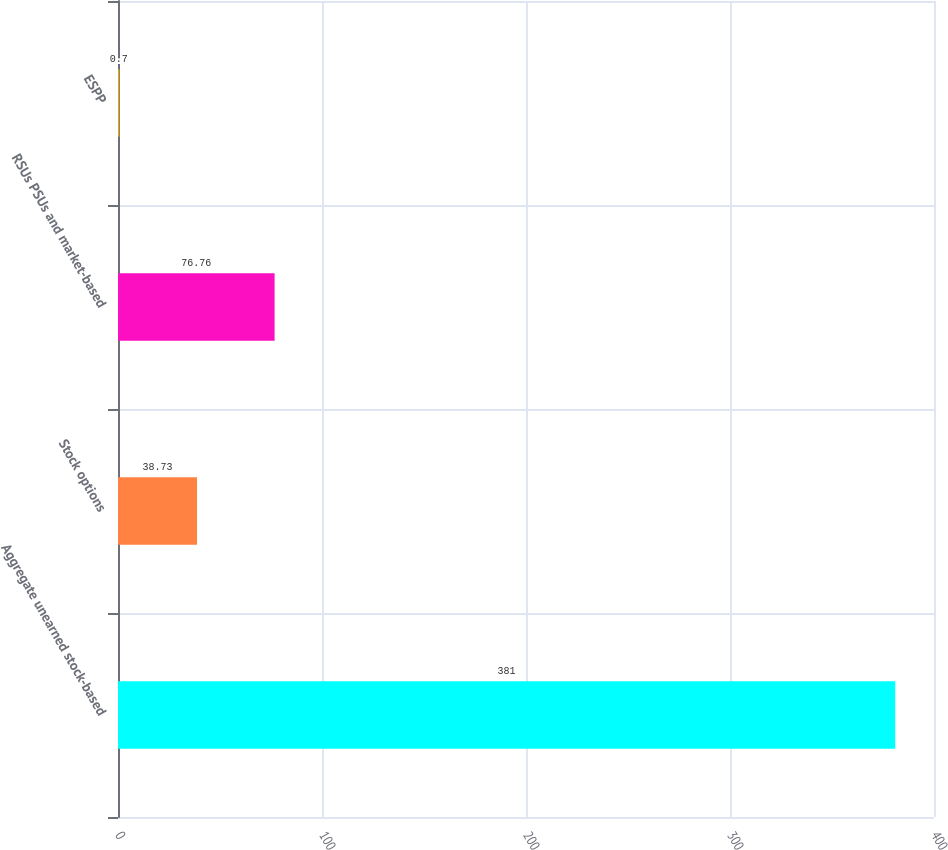Convert chart. <chart><loc_0><loc_0><loc_500><loc_500><bar_chart><fcel>Aggregate unearned stock-based<fcel>Stock options<fcel>RSUs PSUs and market-based<fcel>ESPP<nl><fcel>381<fcel>38.73<fcel>76.76<fcel>0.7<nl></chart> 